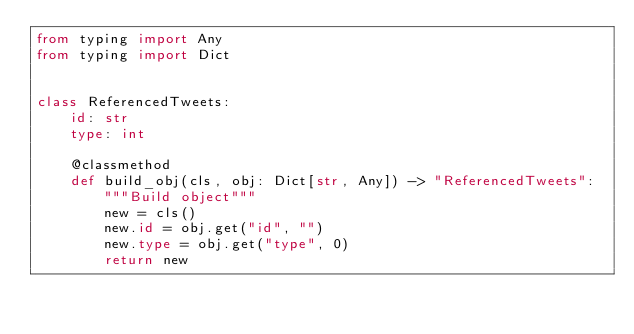Convert code to text. <code><loc_0><loc_0><loc_500><loc_500><_Python_>from typing import Any
from typing import Dict


class ReferencedTweets:
    id: str
    type: int

    @classmethod
    def build_obj(cls, obj: Dict[str, Any]) -> "ReferencedTweets":
        """Build object"""
        new = cls()
        new.id = obj.get("id", "")
        new.type = obj.get("type", 0)
        return new
</code> 